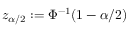Convert formula to latex. <formula><loc_0><loc_0><loc_500><loc_500>z _ { \alpha / 2 } \colon = \Phi ^ { - 1 } ( 1 - \alpha / 2 )</formula> 